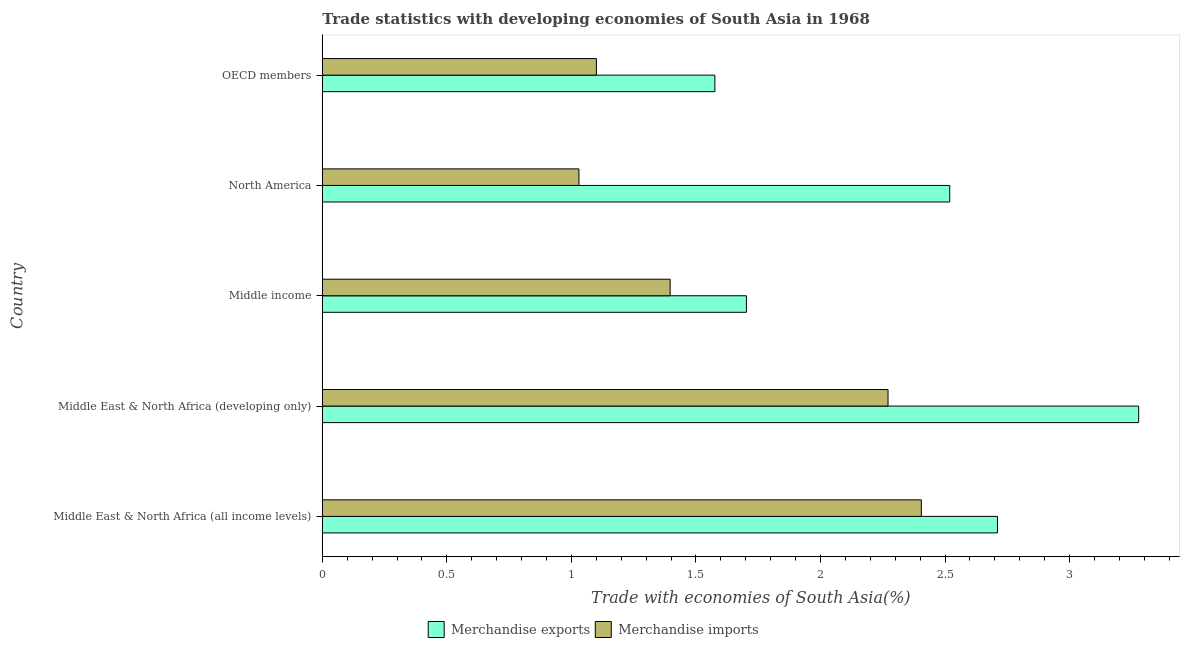How many bars are there on the 1st tick from the top?
Offer a terse response. 2. What is the merchandise imports in Middle East & North Africa (all income levels)?
Make the answer very short. 2.4. Across all countries, what is the maximum merchandise imports?
Provide a succinct answer. 2.4. Across all countries, what is the minimum merchandise imports?
Provide a succinct answer. 1.03. In which country was the merchandise exports maximum?
Offer a very short reply. Middle East & North Africa (developing only). What is the total merchandise imports in the graph?
Keep it short and to the point. 8.2. What is the difference between the merchandise imports in Middle East & North Africa (all income levels) and that in Middle income?
Make the answer very short. 1.01. What is the difference between the merchandise imports in OECD members and the merchandise exports in North America?
Give a very brief answer. -1.42. What is the average merchandise exports per country?
Keep it short and to the point. 2.36. What is the difference between the merchandise exports and merchandise imports in Middle East & North Africa (developing only)?
Keep it short and to the point. 1.01. In how many countries, is the merchandise exports greater than 1.8 %?
Your answer should be very brief. 3. What is the ratio of the merchandise exports in Middle East & North Africa (developing only) to that in OECD members?
Give a very brief answer. 2.08. Is the difference between the merchandise exports in North America and OECD members greater than the difference between the merchandise imports in North America and OECD members?
Keep it short and to the point. Yes. What is the difference between the highest and the second highest merchandise imports?
Your response must be concise. 0.13. What is the difference between the highest and the lowest merchandise exports?
Your answer should be compact. 1.7. Is the sum of the merchandise exports in Middle income and OECD members greater than the maximum merchandise imports across all countries?
Provide a short and direct response. Yes. What is the difference between two consecutive major ticks on the X-axis?
Your answer should be very brief. 0.5. Does the graph contain grids?
Make the answer very short. No. How many legend labels are there?
Keep it short and to the point. 2. What is the title of the graph?
Offer a terse response. Trade statistics with developing economies of South Asia in 1968. Does "Depositors" appear as one of the legend labels in the graph?
Provide a succinct answer. No. What is the label or title of the X-axis?
Give a very brief answer. Trade with economies of South Asia(%). What is the Trade with economies of South Asia(%) in Merchandise exports in Middle East & North Africa (all income levels)?
Your answer should be compact. 2.71. What is the Trade with economies of South Asia(%) in Merchandise imports in Middle East & North Africa (all income levels)?
Your answer should be very brief. 2.4. What is the Trade with economies of South Asia(%) of Merchandise exports in Middle East & North Africa (developing only)?
Provide a succinct answer. 3.28. What is the Trade with economies of South Asia(%) of Merchandise imports in Middle East & North Africa (developing only)?
Ensure brevity in your answer.  2.27. What is the Trade with economies of South Asia(%) of Merchandise exports in Middle income?
Make the answer very short. 1.7. What is the Trade with economies of South Asia(%) in Merchandise imports in Middle income?
Your answer should be compact. 1.4. What is the Trade with economies of South Asia(%) in Merchandise exports in North America?
Make the answer very short. 2.52. What is the Trade with economies of South Asia(%) in Merchandise imports in North America?
Your answer should be compact. 1.03. What is the Trade with economies of South Asia(%) of Merchandise exports in OECD members?
Keep it short and to the point. 1.58. What is the Trade with economies of South Asia(%) in Merchandise imports in OECD members?
Offer a very short reply. 1.1. Across all countries, what is the maximum Trade with economies of South Asia(%) of Merchandise exports?
Give a very brief answer. 3.28. Across all countries, what is the maximum Trade with economies of South Asia(%) of Merchandise imports?
Give a very brief answer. 2.4. Across all countries, what is the minimum Trade with economies of South Asia(%) in Merchandise exports?
Keep it short and to the point. 1.58. Across all countries, what is the minimum Trade with economies of South Asia(%) in Merchandise imports?
Keep it short and to the point. 1.03. What is the total Trade with economies of South Asia(%) in Merchandise exports in the graph?
Make the answer very short. 11.79. What is the total Trade with economies of South Asia(%) of Merchandise imports in the graph?
Your answer should be very brief. 8.2. What is the difference between the Trade with economies of South Asia(%) of Merchandise exports in Middle East & North Africa (all income levels) and that in Middle East & North Africa (developing only)?
Keep it short and to the point. -0.57. What is the difference between the Trade with economies of South Asia(%) in Merchandise imports in Middle East & North Africa (all income levels) and that in Middle East & North Africa (developing only)?
Provide a short and direct response. 0.13. What is the difference between the Trade with economies of South Asia(%) of Merchandise exports in Middle East & North Africa (all income levels) and that in Middle income?
Make the answer very short. 1.01. What is the difference between the Trade with economies of South Asia(%) in Merchandise imports in Middle East & North Africa (all income levels) and that in Middle income?
Your answer should be compact. 1.01. What is the difference between the Trade with economies of South Asia(%) in Merchandise exports in Middle East & North Africa (all income levels) and that in North America?
Your answer should be very brief. 0.19. What is the difference between the Trade with economies of South Asia(%) of Merchandise imports in Middle East & North Africa (all income levels) and that in North America?
Ensure brevity in your answer.  1.37. What is the difference between the Trade with economies of South Asia(%) in Merchandise exports in Middle East & North Africa (all income levels) and that in OECD members?
Offer a very short reply. 1.13. What is the difference between the Trade with economies of South Asia(%) in Merchandise imports in Middle East & North Africa (all income levels) and that in OECD members?
Give a very brief answer. 1.3. What is the difference between the Trade with economies of South Asia(%) in Merchandise exports in Middle East & North Africa (developing only) and that in Middle income?
Make the answer very short. 1.57. What is the difference between the Trade with economies of South Asia(%) of Merchandise imports in Middle East & North Africa (developing only) and that in Middle income?
Keep it short and to the point. 0.87. What is the difference between the Trade with economies of South Asia(%) in Merchandise exports in Middle East & North Africa (developing only) and that in North America?
Provide a succinct answer. 0.76. What is the difference between the Trade with economies of South Asia(%) of Merchandise imports in Middle East & North Africa (developing only) and that in North America?
Provide a short and direct response. 1.24. What is the difference between the Trade with economies of South Asia(%) in Merchandise exports in Middle East & North Africa (developing only) and that in OECD members?
Your response must be concise. 1.7. What is the difference between the Trade with economies of South Asia(%) of Merchandise imports in Middle East & North Africa (developing only) and that in OECD members?
Your answer should be compact. 1.17. What is the difference between the Trade with economies of South Asia(%) in Merchandise exports in Middle income and that in North America?
Keep it short and to the point. -0.82. What is the difference between the Trade with economies of South Asia(%) in Merchandise imports in Middle income and that in North America?
Your answer should be very brief. 0.37. What is the difference between the Trade with economies of South Asia(%) in Merchandise exports in Middle income and that in OECD members?
Offer a very short reply. 0.13. What is the difference between the Trade with economies of South Asia(%) in Merchandise imports in Middle income and that in OECD members?
Your answer should be very brief. 0.3. What is the difference between the Trade with economies of South Asia(%) of Merchandise exports in North America and that in OECD members?
Keep it short and to the point. 0.94. What is the difference between the Trade with economies of South Asia(%) of Merchandise imports in North America and that in OECD members?
Your answer should be compact. -0.07. What is the difference between the Trade with economies of South Asia(%) of Merchandise exports in Middle East & North Africa (all income levels) and the Trade with economies of South Asia(%) of Merchandise imports in Middle East & North Africa (developing only)?
Your response must be concise. 0.44. What is the difference between the Trade with economies of South Asia(%) of Merchandise exports in Middle East & North Africa (all income levels) and the Trade with economies of South Asia(%) of Merchandise imports in Middle income?
Your response must be concise. 1.31. What is the difference between the Trade with economies of South Asia(%) of Merchandise exports in Middle East & North Africa (all income levels) and the Trade with economies of South Asia(%) of Merchandise imports in North America?
Ensure brevity in your answer.  1.68. What is the difference between the Trade with economies of South Asia(%) of Merchandise exports in Middle East & North Africa (all income levels) and the Trade with economies of South Asia(%) of Merchandise imports in OECD members?
Provide a short and direct response. 1.61. What is the difference between the Trade with economies of South Asia(%) of Merchandise exports in Middle East & North Africa (developing only) and the Trade with economies of South Asia(%) of Merchandise imports in Middle income?
Your answer should be compact. 1.88. What is the difference between the Trade with economies of South Asia(%) of Merchandise exports in Middle East & North Africa (developing only) and the Trade with economies of South Asia(%) of Merchandise imports in North America?
Offer a terse response. 2.25. What is the difference between the Trade with economies of South Asia(%) in Merchandise exports in Middle East & North Africa (developing only) and the Trade with economies of South Asia(%) in Merchandise imports in OECD members?
Keep it short and to the point. 2.18. What is the difference between the Trade with economies of South Asia(%) in Merchandise exports in Middle income and the Trade with economies of South Asia(%) in Merchandise imports in North America?
Your answer should be compact. 0.67. What is the difference between the Trade with economies of South Asia(%) in Merchandise exports in Middle income and the Trade with economies of South Asia(%) in Merchandise imports in OECD members?
Your answer should be compact. 0.6. What is the difference between the Trade with economies of South Asia(%) in Merchandise exports in North America and the Trade with economies of South Asia(%) in Merchandise imports in OECD members?
Your answer should be compact. 1.42. What is the average Trade with economies of South Asia(%) of Merchandise exports per country?
Your answer should be compact. 2.36. What is the average Trade with economies of South Asia(%) of Merchandise imports per country?
Ensure brevity in your answer.  1.64. What is the difference between the Trade with economies of South Asia(%) of Merchandise exports and Trade with economies of South Asia(%) of Merchandise imports in Middle East & North Africa (all income levels)?
Provide a short and direct response. 0.31. What is the difference between the Trade with economies of South Asia(%) in Merchandise exports and Trade with economies of South Asia(%) in Merchandise imports in Middle income?
Offer a terse response. 0.31. What is the difference between the Trade with economies of South Asia(%) of Merchandise exports and Trade with economies of South Asia(%) of Merchandise imports in North America?
Offer a very short reply. 1.49. What is the difference between the Trade with economies of South Asia(%) in Merchandise exports and Trade with economies of South Asia(%) in Merchandise imports in OECD members?
Your response must be concise. 0.48. What is the ratio of the Trade with economies of South Asia(%) of Merchandise exports in Middle East & North Africa (all income levels) to that in Middle East & North Africa (developing only)?
Give a very brief answer. 0.83. What is the ratio of the Trade with economies of South Asia(%) in Merchandise imports in Middle East & North Africa (all income levels) to that in Middle East & North Africa (developing only)?
Offer a terse response. 1.06. What is the ratio of the Trade with economies of South Asia(%) in Merchandise exports in Middle East & North Africa (all income levels) to that in Middle income?
Make the answer very short. 1.59. What is the ratio of the Trade with economies of South Asia(%) in Merchandise imports in Middle East & North Africa (all income levels) to that in Middle income?
Make the answer very short. 1.72. What is the ratio of the Trade with economies of South Asia(%) in Merchandise exports in Middle East & North Africa (all income levels) to that in North America?
Keep it short and to the point. 1.08. What is the ratio of the Trade with economies of South Asia(%) of Merchandise imports in Middle East & North Africa (all income levels) to that in North America?
Your answer should be compact. 2.33. What is the ratio of the Trade with economies of South Asia(%) of Merchandise exports in Middle East & North Africa (all income levels) to that in OECD members?
Offer a very short reply. 1.72. What is the ratio of the Trade with economies of South Asia(%) of Merchandise imports in Middle East & North Africa (all income levels) to that in OECD members?
Give a very brief answer. 2.19. What is the ratio of the Trade with economies of South Asia(%) of Merchandise exports in Middle East & North Africa (developing only) to that in Middle income?
Your answer should be very brief. 1.92. What is the ratio of the Trade with economies of South Asia(%) of Merchandise imports in Middle East & North Africa (developing only) to that in Middle income?
Make the answer very short. 1.63. What is the ratio of the Trade with economies of South Asia(%) of Merchandise exports in Middle East & North Africa (developing only) to that in North America?
Your response must be concise. 1.3. What is the ratio of the Trade with economies of South Asia(%) in Merchandise imports in Middle East & North Africa (developing only) to that in North America?
Your answer should be very brief. 2.2. What is the ratio of the Trade with economies of South Asia(%) in Merchandise exports in Middle East & North Africa (developing only) to that in OECD members?
Provide a succinct answer. 2.08. What is the ratio of the Trade with economies of South Asia(%) in Merchandise imports in Middle East & North Africa (developing only) to that in OECD members?
Give a very brief answer. 2.06. What is the ratio of the Trade with economies of South Asia(%) in Merchandise exports in Middle income to that in North America?
Give a very brief answer. 0.68. What is the ratio of the Trade with economies of South Asia(%) of Merchandise imports in Middle income to that in North America?
Give a very brief answer. 1.36. What is the ratio of the Trade with economies of South Asia(%) of Merchandise exports in Middle income to that in OECD members?
Provide a short and direct response. 1.08. What is the ratio of the Trade with economies of South Asia(%) of Merchandise imports in Middle income to that in OECD members?
Provide a short and direct response. 1.27. What is the ratio of the Trade with economies of South Asia(%) in Merchandise exports in North America to that in OECD members?
Keep it short and to the point. 1.6. What is the ratio of the Trade with economies of South Asia(%) in Merchandise imports in North America to that in OECD members?
Ensure brevity in your answer.  0.94. What is the difference between the highest and the second highest Trade with economies of South Asia(%) of Merchandise exports?
Offer a very short reply. 0.57. What is the difference between the highest and the second highest Trade with economies of South Asia(%) in Merchandise imports?
Your response must be concise. 0.13. What is the difference between the highest and the lowest Trade with economies of South Asia(%) in Merchandise exports?
Provide a short and direct response. 1.7. What is the difference between the highest and the lowest Trade with economies of South Asia(%) in Merchandise imports?
Provide a short and direct response. 1.37. 